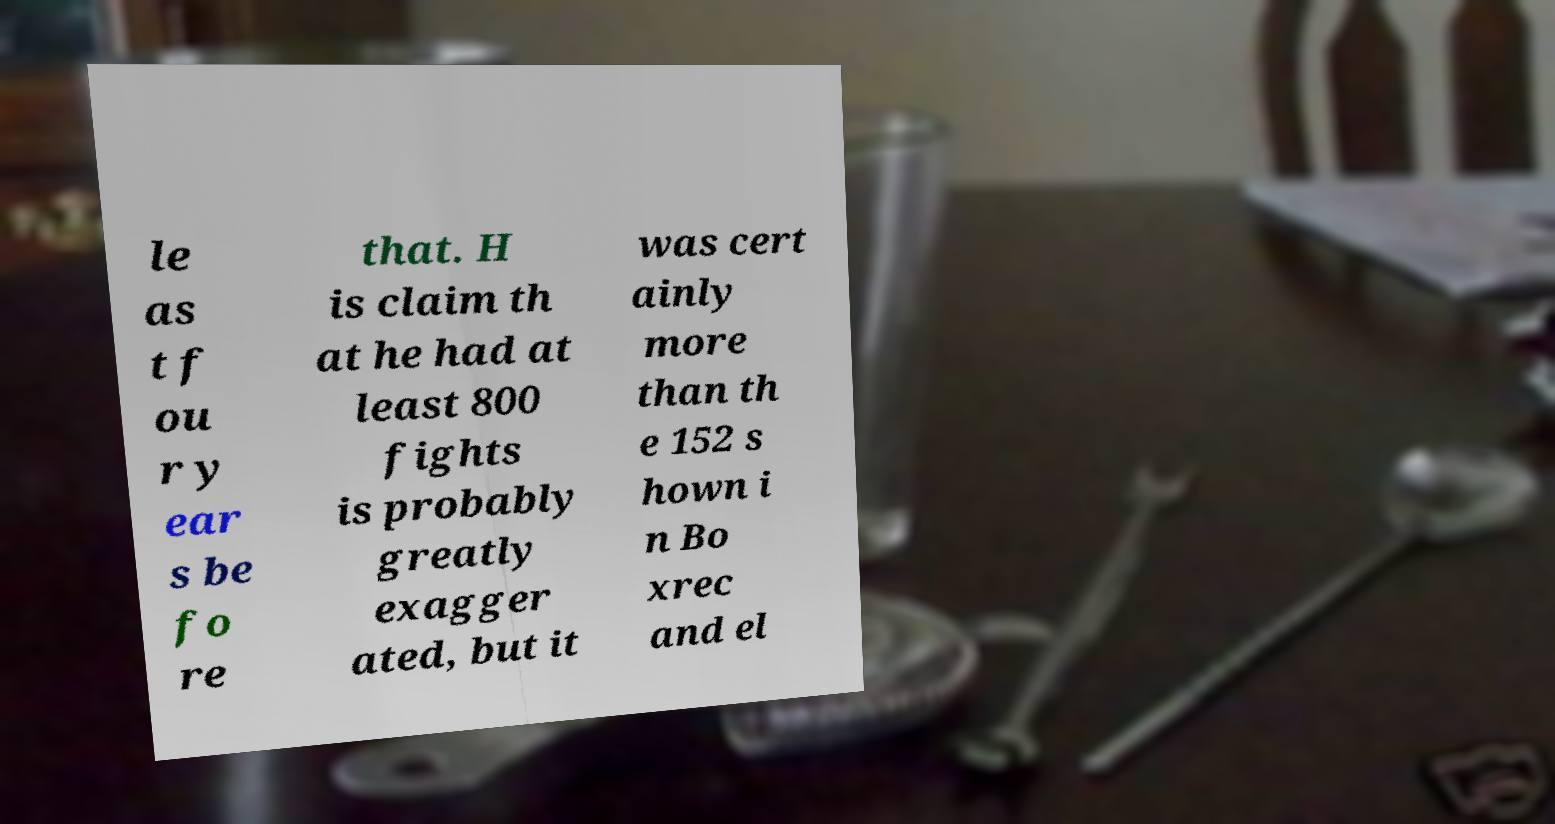Please read and relay the text visible in this image. What does it say? le as t f ou r y ear s be fo re that. H is claim th at he had at least 800 fights is probably greatly exagger ated, but it was cert ainly more than th e 152 s hown i n Bo xrec and el 